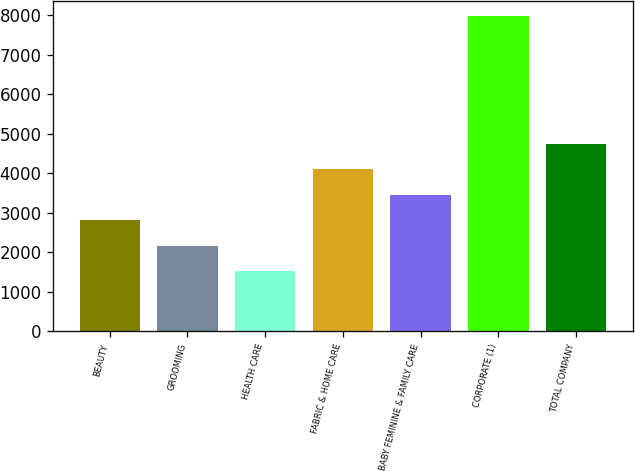Convert chart to OTSL. <chart><loc_0><loc_0><loc_500><loc_500><bar_chart><fcel>BEAUTY<fcel>GROOMING<fcel>HEALTH CARE<fcel>FABRIC & HOME CARE<fcel>BABY FEMININE & FAMILY CARE<fcel>CORPORATE (1)<fcel>TOTAL COMPANY<nl><fcel>2809.4<fcel>2164.2<fcel>1519<fcel>4099.8<fcel>3454.6<fcel>7971<fcel>4745<nl></chart> 